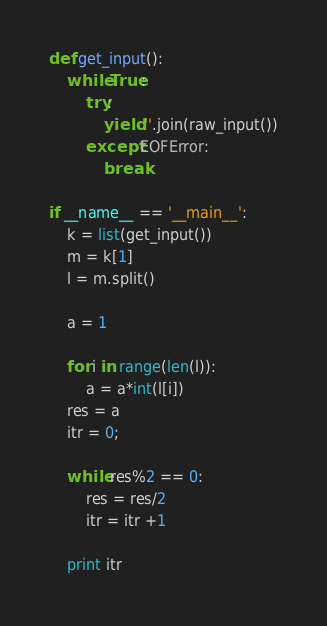<code> <loc_0><loc_0><loc_500><loc_500><_Python_>def get_input():
    while True:
        try:
            yield ''.join(raw_input())
        except EOFError:
            break

if __name__ == '__main__':
    k = list(get_input())
    m = k[1]
    l = m.split()
    
    a = 1

    for i in range(len(l)):
        a = a*int(l[i]) 
    res = a
    itr = 0;
    
    while res%2 == 0:
        res = res/2
        itr = itr +1

    print itr</code> 